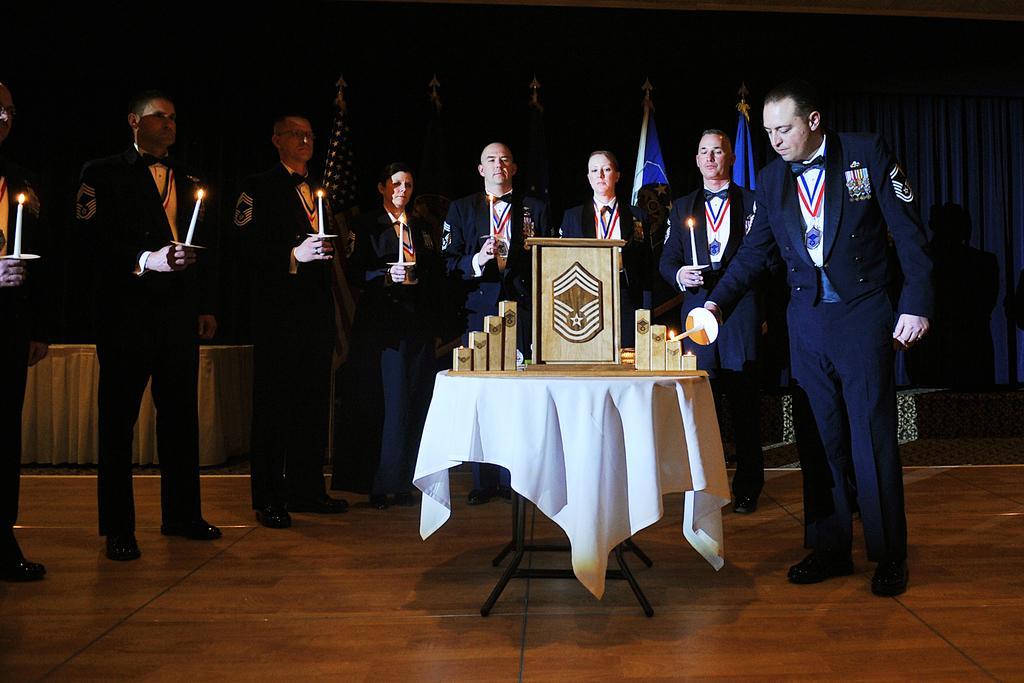Please provide a concise description of this image. In this image I can see few people are standing and all of them are holding candles. Here I can see a table and a tablecloth. In the background I can see few flags. 